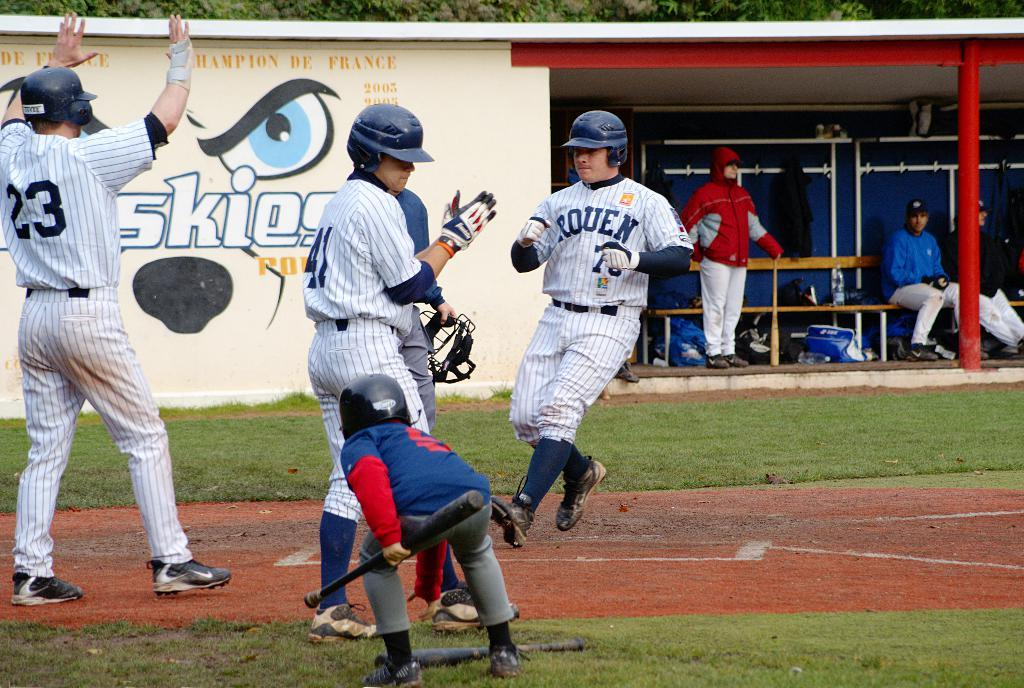<image>
Give a short and clear explanation of the subsequent image. The player wearing the 23 top has his hands in the air celebrating. 